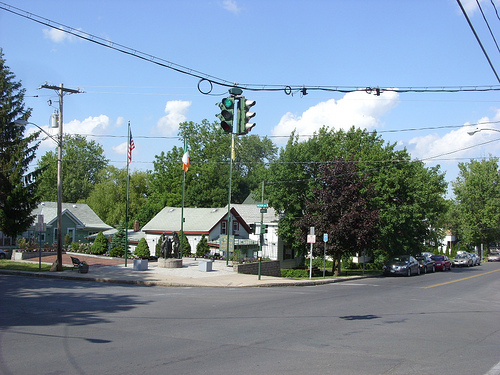What can be inferred about the location based on the image? Based on the image, we can infer that this is a small town or suburban area. The modest architecture, well-kept lawns, and absence of high-rise buildings suggest a peaceful residential community or a town center with a focus on local history and community values. 